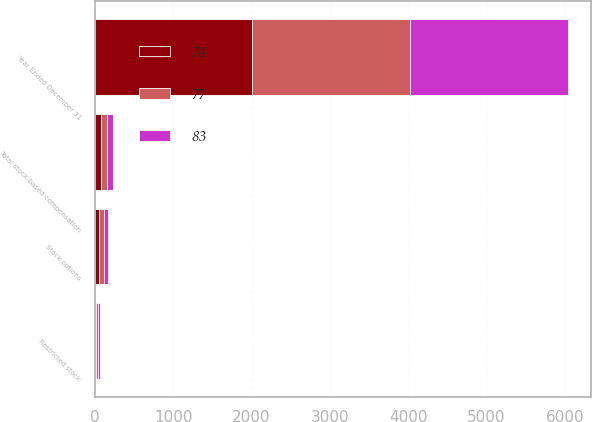Convert chart. <chart><loc_0><loc_0><loc_500><loc_500><stacked_bar_chart><ecel><fcel>Year Ended December 31<fcel>Stock options<fcel>Restricted stock<fcel>Total stock-based compensation<nl><fcel>83<fcel>2010<fcel>53<fcel>24<fcel>77<nl><fcel>77<fcel>2011<fcel>58<fcel>25<fcel>83<nl><fcel>74<fcel>2012<fcel>57<fcel>17<fcel>74<nl></chart> 